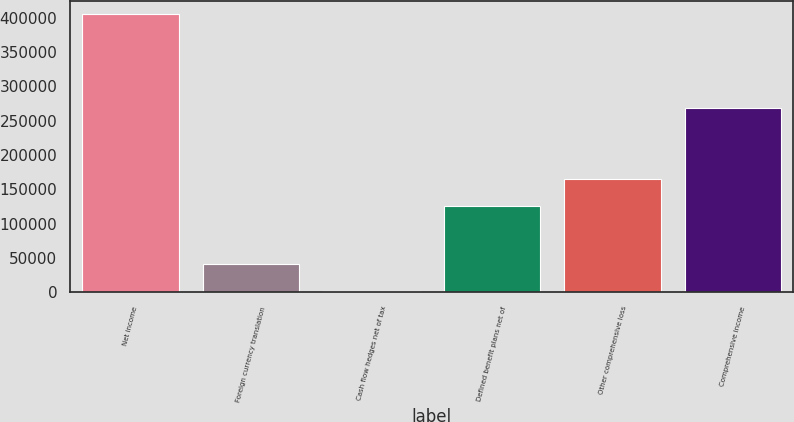Convert chart. <chart><loc_0><loc_0><loc_500><loc_500><bar_chart><fcel>Net income<fcel>Foreign currency translation<fcel>Cash flow hedges net of tax<fcel>Defined benefit plans net of<fcel>Other comprehensive loss<fcel>Comprehensive income<nl><fcel>404519<fcel>41963<fcel>1679<fcel>125080<fcel>165364<fcel>268947<nl></chart> 